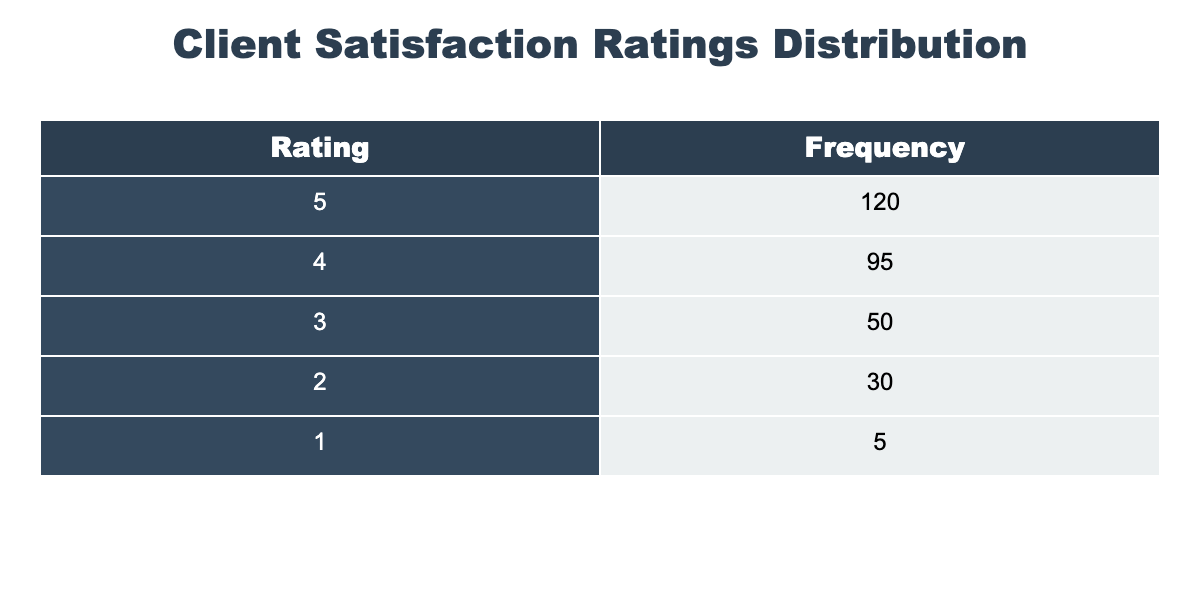What is the highest client satisfaction rating recorded? From the frequency distribution table, the highest rating listed is 5, which has a frequency of 120.
Answer: 5 What is the total number of feedback responses collected? To find the total number of feedback responses, sum the frequencies of all ratings: 120 (for rating 5) + 95 (for rating 4) + 50 (for rating 3) + 30 (for rating 2) + 5 (for rating 1) = 300.
Answer: 300 How many clients rated their satisfaction with a score of 1 or 2? To find the number of clients who rated 1 or 2, combine the frequencies for those ratings: 5 (for rating 1) + 30 (for rating 2) = 35.
Answer: 35 What percentage of clients provided a rating of 4 or 5? First, add the frequencies of ratings 4 and 5: 95 + 120 = 215. Then, calculate the percentage of these ratings relative to the total: (215 / 300) * 100 = 71.67%.
Answer: 71.67% Is it true that more than half of the clients rated their satisfaction above 3? To check this, first calculate the total number of clients who rated 3 or below: 50 (for rating 3) + 30 (for rating 2) + 5 (for rating 1) = 85. Now, subtract this from the total: 300 - 85 = 215, which is more than half.
Answer: Yes What is the difference in frequency between ratings of 5 and 3? The frequency for rating 5 is 120, and for rating 3 it is 50. The difference is calculated as 120 - 50 = 70.
Answer: 70 How many more clients rated their satisfaction as 5 compared to those who rated it as 1? The frequency for rating 5 is 120 and for rating 1 is 5. The difference is 120 - 5 = 115.
Answer: 115 What is the average rating based on the frequencies provided? To find the average rating, multiply each rating by its frequency, sum those products, and then divide by the total number of responses. Average = (5*120 + 4*95 + 3*50 + 2*30 + 1*5) / 300 = (600 + 380 + 150 + 60 + 5) / 300 = 1195 / 300 = 3.98.
Answer: 3.98 